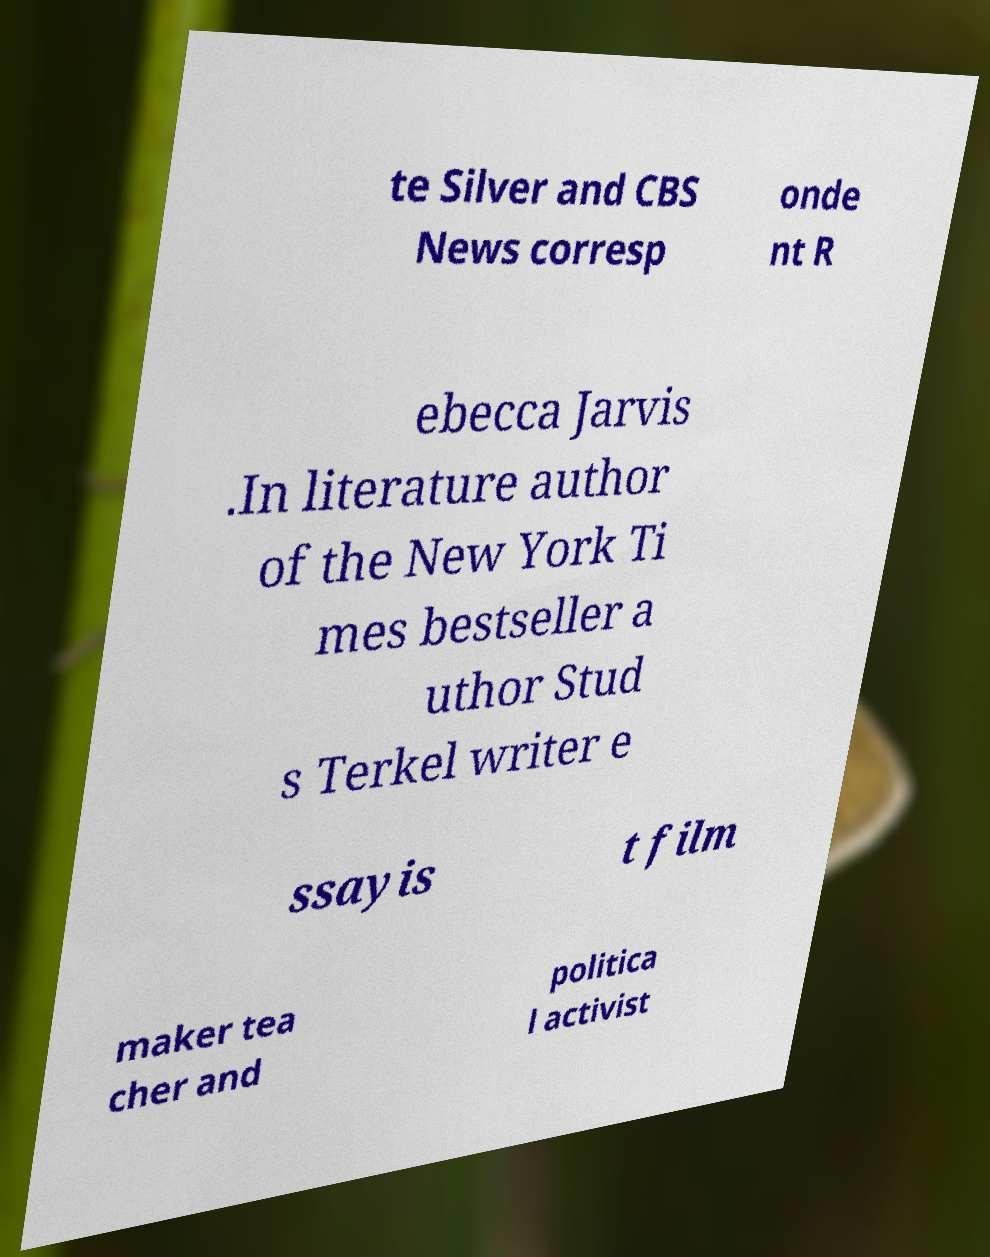Please read and relay the text visible in this image. What does it say? te Silver and CBS News corresp onde nt R ebecca Jarvis .In literature author of the New York Ti mes bestseller a uthor Stud s Terkel writer e ssayis t film maker tea cher and politica l activist 